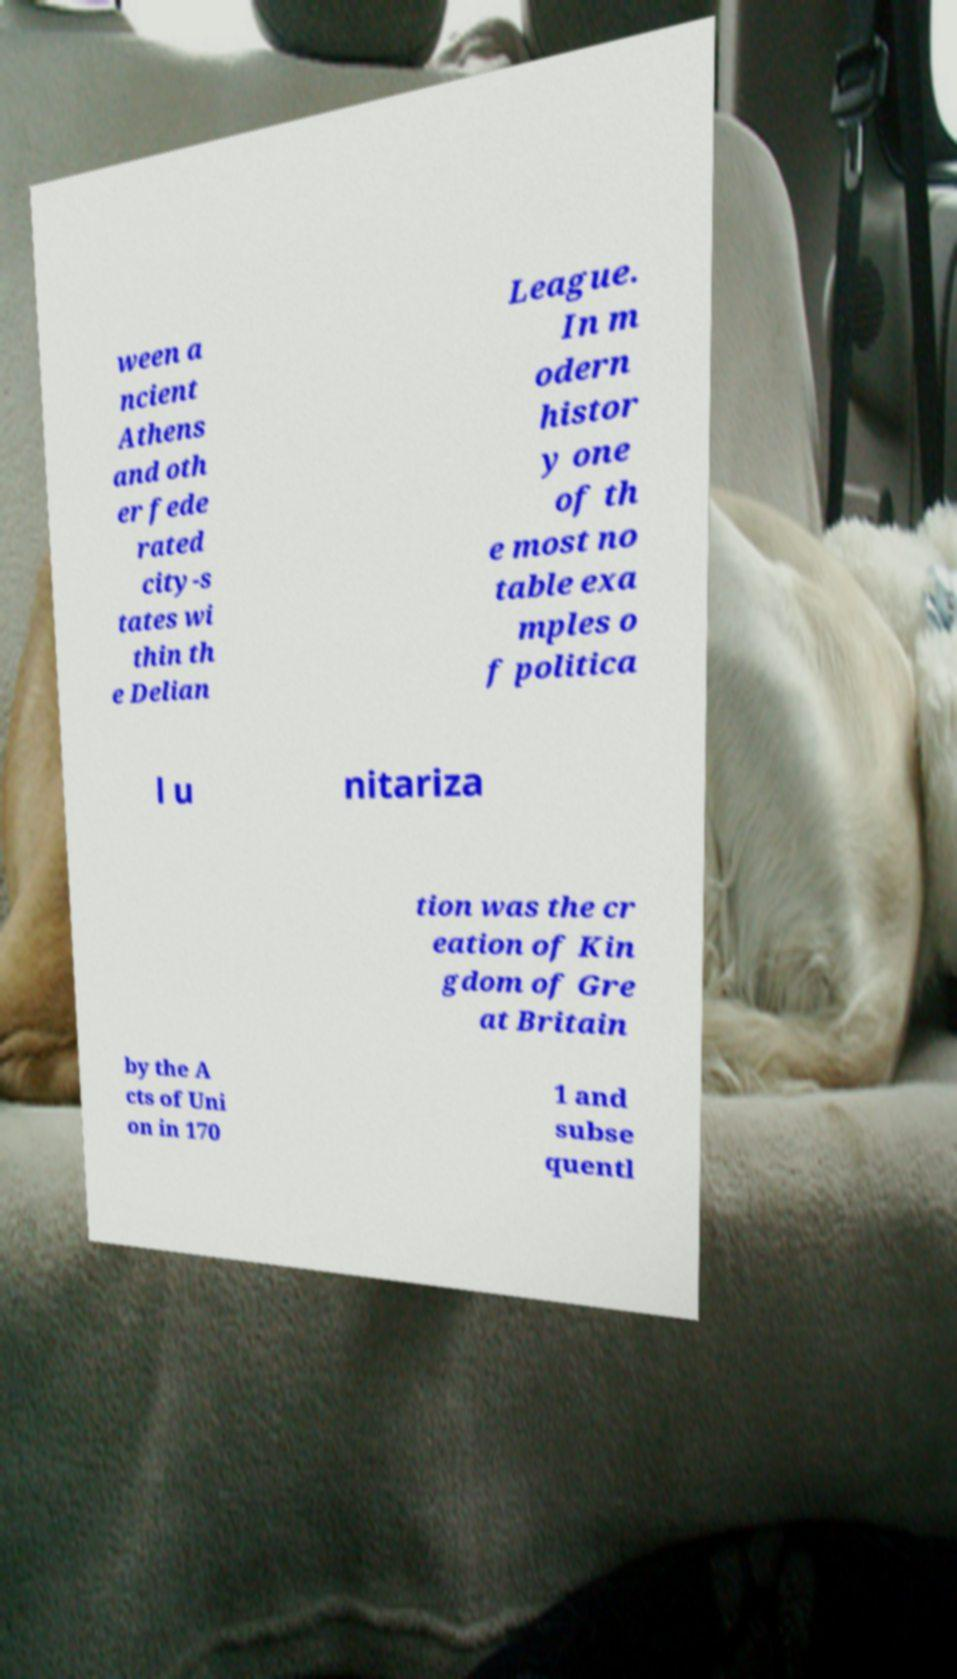I need the written content from this picture converted into text. Can you do that? ween a ncient Athens and oth er fede rated city-s tates wi thin th e Delian League. In m odern histor y one of th e most no table exa mples o f politica l u nitariza tion was the cr eation of Kin gdom of Gre at Britain by the A cts of Uni on in 170 1 and subse quentl 